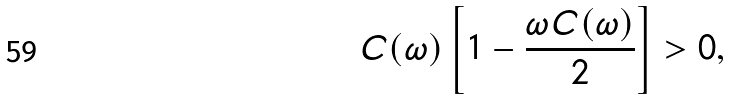Convert formula to latex. <formula><loc_0><loc_0><loc_500><loc_500>C ( \omega ) \left [ 1 - \frac { \omega C ( \omega ) } { 2 } \right ] > 0 ,</formula> 